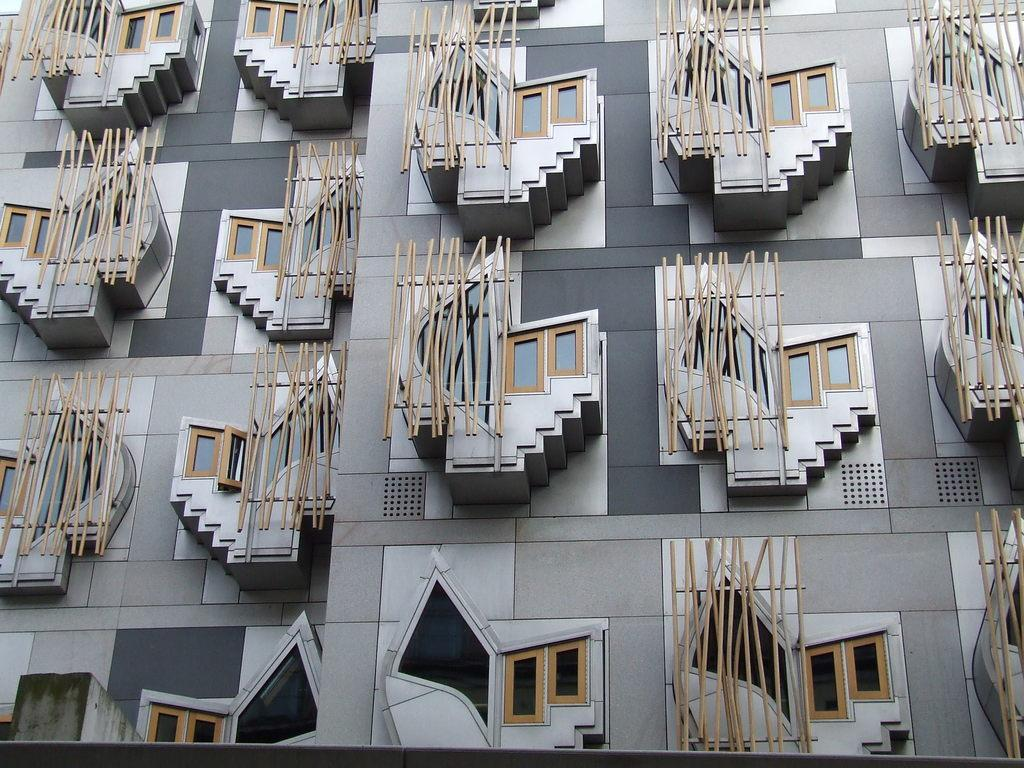What type of structure is present in the image? There is a building in the image. Can you describe the color scheme of the building? The building has a grey, white, and black color scheme. What color are the windows on the building? The windows on the building are brown. How does the building change its appearance during an earthquake in the image? There is no earthquake depicted in the image, and therefore no change in the building's appearance can be observed. 